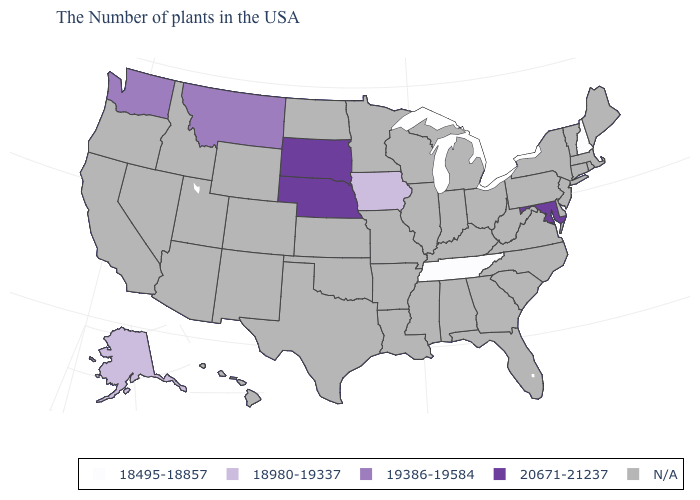What is the highest value in the USA?
Be succinct. 20671-21237. What is the value of Louisiana?
Short answer required. N/A. Name the states that have a value in the range N/A?
Give a very brief answer. Maine, Massachusetts, Rhode Island, Vermont, Connecticut, New York, New Jersey, Delaware, Pennsylvania, Virginia, North Carolina, South Carolina, West Virginia, Ohio, Florida, Georgia, Michigan, Kentucky, Indiana, Alabama, Wisconsin, Illinois, Mississippi, Louisiana, Missouri, Arkansas, Minnesota, Kansas, Oklahoma, Texas, North Dakota, Wyoming, Colorado, New Mexico, Utah, Arizona, Idaho, Nevada, California, Oregon, Hawaii. Name the states that have a value in the range 20671-21237?
Answer briefly. Maryland, Nebraska, South Dakota. Which states have the highest value in the USA?
Answer briefly. Maryland, Nebraska, South Dakota. Which states have the lowest value in the USA?
Quick response, please. New Hampshire, Tennessee. Does the map have missing data?
Quick response, please. Yes. Name the states that have a value in the range 19386-19584?
Give a very brief answer. Montana, Washington. What is the value of Kentucky?
Quick response, please. N/A. How many symbols are there in the legend?
Keep it brief. 5. 